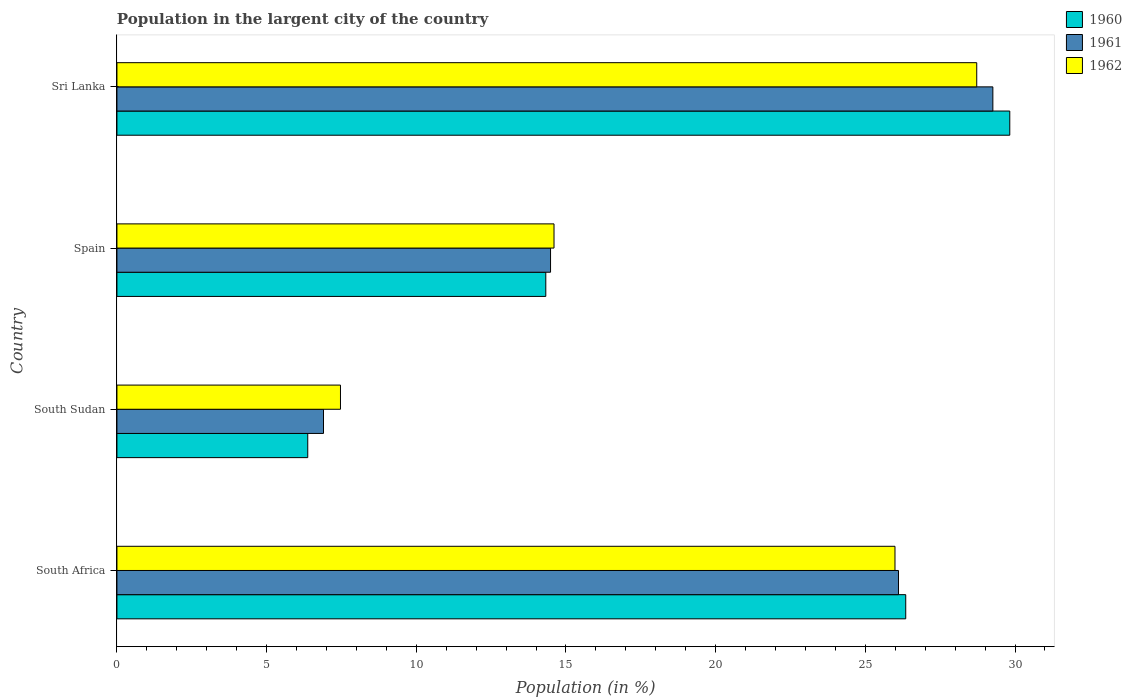How many different coloured bars are there?
Keep it short and to the point. 3. Are the number of bars on each tick of the Y-axis equal?
Offer a terse response. Yes. How many bars are there on the 2nd tick from the top?
Your answer should be very brief. 3. How many bars are there on the 2nd tick from the bottom?
Provide a short and direct response. 3. What is the label of the 1st group of bars from the top?
Provide a succinct answer. Sri Lanka. What is the percentage of population in the largent city in 1960 in Sri Lanka?
Give a very brief answer. 29.82. Across all countries, what is the maximum percentage of population in the largent city in 1960?
Provide a short and direct response. 29.82. Across all countries, what is the minimum percentage of population in the largent city in 1961?
Provide a succinct answer. 6.9. In which country was the percentage of population in the largent city in 1960 maximum?
Your answer should be very brief. Sri Lanka. In which country was the percentage of population in the largent city in 1960 minimum?
Offer a terse response. South Sudan. What is the total percentage of population in the largent city in 1961 in the graph?
Keep it short and to the point. 76.75. What is the difference between the percentage of population in the largent city in 1961 in South Sudan and that in Spain?
Provide a succinct answer. -7.58. What is the difference between the percentage of population in the largent city in 1962 in Spain and the percentage of population in the largent city in 1960 in South Sudan?
Give a very brief answer. 8.23. What is the average percentage of population in the largent city in 1962 per country?
Provide a succinct answer. 19.19. What is the difference between the percentage of population in the largent city in 1960 and percentage of population in the largent city in 1962 in Sri Lanka?
Keep it short and to the point. 1.1. What is the ratio of the percentage of population in the largent city in 1961 in South Sudan to that in Spain?
Give a very brief answer. 0.48. What is the difference between the highest and the second highest percentage of population in the largent city in 1962?
Provide a succinct answer. 2.73. What is the difference between the highest and the lowest percentage of population in the largent city in 1961?
Provide a succinct answer. 22.36. In how many countries, is the percentage of population in the largent city in 1962 greater than the average percentage of population in the largent city in 1962 taken over all countries?
Your answer should be very brief. 2. What is the difference between two consecutive major ticks on the X-axis?
Your answer should be very brief. 5. Are the values on the major ticks of X-axis written in scientific E-notation?
Keep it short and to the point. No. Does the graph contain any zero values?
Offer a very short reply. No. Does the graph contain grids?
Make the answer very short. No. How are the legend labels stacked?
Provide a short and direct response. Vertical. What is the title of the graph?
Ensure brevity in your answer.  Population in the largent city of the country. What is the label or title of the Y-axis?
Keep it short and to the point. Country. What is the Population (in %) in 1960 in South Africa?
Give a very brief answer. 26.35. What is the Population (in %) in 1961 in South Africa?
Your response must be concise. 26.11. What is the Population (in %) of 1962 in South Africa?
Your answer should be very brief. 25.99. What is the Population (in %) of 1960 in South Sudan?
Make the answer very short. 6.37. What is the Population (in %) of 1961 in South Sudan?
Your answer should be compact. 6.9. What is the Population (in %) in 1962 in South Sudan?
Ensure brevity in your answer.  7.47. What is the Population (in %) in 1960 in Spain?
Provide a succinct answer. 14.33. What is the Population (in %) of 1961 in Spain?
Provide a short and direct response. 14.48. What is the Population (in %) of 1962 in Spain?
Make the answer very short. 14.6. What is the Population (in %) in 1960 in Sri Lanka?
Provide a succinct answer. 29.82. What is the Population (in %) in 1961 in Sri Lanka?
Offer a terse response. 29.26. What is the Population (in %) in 1962 in Sri Lanka?
Give a very brief answer. 28.72. Across all countries, what is the maximum Population (in %) in 1960?
Make the answer very short. 29.82. Across all countries, what is the maximum Population (in %) of 1961?
Ensure brevity in your answer.  29.26. Across all countries, what is the maximum Population (in %) in 1962?
Ensure brevity in your answer.  28.72. Across all countries, what is the minimum Population (in %) in 1960?
Offer a terse response. 6.37. Across all countries, what is the minimum Population (in %) in 1961?
Keep it short and to the point. 6.9. Across all countries, what is the minimum Population (in %) in 1962?
Ensure brevity in your answer.  7.47. What is the total Population (in %) of 1960 in the graph?
Offer a terse response. 76.87. What is the total Population (in %) of 1961 in the graph?
Provide a short and direct response. 76.75. What is the total Population (in %) in 1962 in the graph?
Provide a short and direct response. 76.78. What is the difference between the Population (in %) of 1960 in South Africa and that in South Sudan?
Offer a terse response. 19.97. What is the difference between the Population (in %) in 1961 in South Africa and that in South Sudan?
Provide a short and direct response. 19.21. What is the difference between the Population (in %) of 1962 in South Africa and that in South Sudan?
Ensure brevity in your answer.  18.52. What is the difference between the Population (in %) in 1960 in South Africa and that in Spain?
Your answer should be very brief. 12.02. What is the difference between the Population (in %) in 1961 in South Africa and that in Spain?
Your response must be concise. 11.62. What is the difference between the Population (in %) in 1962 in South Africa and that in Spain?
Keep it short and to the point. 11.39. What is the difference between the Population (in %) in 1960 in South Africa and that in Sri Lanka?
Provide a succinct answer. -3.48. What is the difference between the Population (in %) of 1961 in South Africa and that in Sri Lanka?
Your answer should be compact. -3.15. What is the difference between the Population (in %) of 1962 in South Africa and that in Sri Lanka?
Ensure brevity in your answer.  -2.73. What is the difference between the Population (in %) of 1960 in South Sudan and that in Spain?
Provide a short and direct response. -7.95. What is the difference between the Population (in %) in 1961 in South Sudan and that in Spain?
Offer a very short reply. -7.58. What is the difference between the Population (in %) of 1962 in South Sudan and that in Spain?
Provide a succinct answer. -7.13. What is the difference between the Population (in %) in 1960 in South Sudan and that in Sri Lanka?
Provide a succinct answer. -23.45. What is the difference between the Population (in %) of 1961 in South Sudan and that in Sri Lanka?
Give a very brief answer. -22.36. What is the difference between the Population (in %) in 1962 in South Sudan and that in Sri Lanka?
Offer a very short reply. -21.25. What is the difference between the Population (in %) in 1960 in Spain and that in Sri Lanka?
Your answer should be very brief. -15.5. What is the difference between the Population (in %) in 1961 in Spain and that in Sri Lanka?
Provide a short and direct response. -14.78. What is the difference between the Population (in %) of 1962 in Spain and that in Sri Lanka?
Your answer should be very brief. -14.12. What is the difference between the Population (in %) of 1960 in South Africa and the Population (in %) of 1961 in South Sudan?
Provide a short and direct response. 19.45. What is the difference between the Population (in %) of 1960 in South Africa and the Population (in %) of 1962 in South Sudan?
Give a very brief answer. 18.88. What is the difference between the Population (in %) in 1961 in South Africa and the Population (in %) in 1962 in South Sudan?
Ensure brevity in your answer.  18.64. What is the difference between the Population (in %) of 1960 in South Africa and the Population (in %) of 1961 in Spain?
Provide a short and direct response. 11.86. What is the difference between the Population (in %) of 1960 in South Africa and the Population (in %) of 1962 in Spain?
Offer a terse response. 11.75. What is the difference between the Population (in %) in 1961 in South Africa and the Population (in %) in 1962 in Spain?
Offer a very short reply. 11.51. What is the difference between the Population (in %) of 1960 in South Africa and the Population (in %) of 1961 in Sri Lanka?
Offer a very short reply. -2.91. What is the difference between the Population (in %) in 1960 in South Africa and the Population (in %) in 1962 in Sri Lanka?
Your response must be concise. -2.37. What is the difference between the Population (in %) in 1961 in South Africa and the Population (in %) in 1962 in Sri Lanka?
Your response must be concise. -2.61. What is the difference between the Population (in %) in 1960 in South Sudan and the Population (in %) in 1961 in Spain?
Your response must be concise. -8.11. What is the difference between the Population (in %) of 1960 in South Sudan and the Population (in %) of 1962 in Spain?
Make the answer very short. -8.23. What is the difference between the Population (in %) in 1961 in South Sudan and the Population (in %) in 1962 in Spain?
Keep it short and to the point. -7.7. What is the difference between the Population (in %) in 1960 in South Sudan and the Population (in %) in 1961 in Sri Lanka?
Offer a terse response. -22.89. What is the difference between the Population (in %) of 1960 in South Sudan and the Population (in %) of 1962 in Sri Lanka?
Ensure brevity in your answer.  -22.35. What is the difference between the Population (in %) of 1961 in South Sudan and the Population (in %) of 1962 in Sri Lanka?
Offer a terse response. -21.82. What is the difference between the Population (in %) in 1960 in Spain and the Population (in %) in 1961 in Sri Lanka?
Your answer should be compact. -14.93. What is the difference between the Population (in %) in 1960 in Spain and the Population (in %) in 1962 in Sri Lanka?
Make the answer very short. -14.39. What is the difference between the Population (in %) of 1961 in Spain and the Population (in %) of 1962 in Sri Lanka?
Your answer should be compact. -14.24. What is the average Population (in %) of 1960 per country?
Keep it short and to the point. 19.22. What is the average Population (in %) of 1961 per country?
Ensure brevity in your answer.  19.19. What is the average Population (in %) in 1962 per country?
Keep it short and to the point. 19.19. What is the difference between the Population (in %) of 1960 and Population (in %) of 1961 in South Africa?
Offer a very short reply. 0.24. What is the difference between the Population (in %) in 1960 and Population (in %) in 1962 in South Africa?
Offer a very short reply. 0.36. What is the difference between the Population (in %) of 1961 and Population (in %) of 1962 in South Africa?
Keep it short and to the point. 0.12. What is the difference between the Population (in %) of 1960 and Population (in %) of 1961 in South Sudan?
Your response must be concise. -0.53. What is the difference between the Population (in %) in 1960 and Population (in %) in 1962 in South Sudan?
Keep it short and to the point. -1.09. What is the difference between the Population (in %) in 1961 and Population (in %) in 1962 in South Sudan?
Make the answer very short. -0.57. What is the difference between the Population (in %) in 1960 and Population (in %) in 1961 in Spain?
Ensure brevity in your answer.  -0.16. What is the difference between the Population (in %) in 1960 and Population (in %) in 1962 in Spain?
Provide a succinct answer. -0.27. What is the difference between the Population (in %) in 1961 and Population (in %) in 1962 in Spain?
Make the answer very short. -0.12. What is the difference between the Population (in %) of 1960 and Population (in %) of 1961 in Sri Lanka?
Your response must be concise. 0.57. What is the difference between the Population (in %) in 1960 and Population (in %) in 1962 in Sri Lanka?
Make the answer very short. 1.1. What is the difference between the Population (in %) of 1961 and Population (in %) of 1962 in Sri Lanka?
Your response must be concise. 0.54. What is the ratio of the Population (in %) in 1960 in South Africa to that in South Sudan?
Give a very brief answer. 4.13. What is the ratio of the Population (in %) in 1961 in South Africa to that in South Sudan?
Provide a short and direct response. 3.78. What is the ratio of the Population (in %) in 1962 in South Africa to that in South Sudan?
Make the answer very short. 3.48. What is the ratio of the Population (in %) in 1960 in South Africa to that in Spain?
Offer a very short reply. 1.84. What is the ratio of the Population (in %) of 1961 in South Africa to that in Spain?
Make the answer very short. 1.8. What is the ratio of the Population (in %) in 1962 in South Africa to that in Spain?
Provide a short and direct response. 1.78. What is the ratio of the Population (in %) in 1960 in South Africa to that in Sri Lanka?
Offer a terse response. 0.88. What is the ratio of the Population (in %) in 1961 in South Africa to that in Sri Lanka?
Make the answer very short. 0.89. What is the ratio of the Population (in %) in 1962 in South Africa to that in Sri Lanka?
Ensure brevity in your answer.  0.9. What is the ratio of the Population (in %) in 1960 in South Sudan to that in Spain?
Keep it short and to the point. 0.44. What is the ratio of the Population (in %) in 1961 in South Sudan to that in Spain?
Ensure brevity in your answer.  0.48. What is the ratio of the Population (in %) of 1962 in South Sudan to that in Spain?
Your answer should be compact. 0.51. What is the ratio of the Population (in %) in 1960 in South Sudan to that in Sri Lanka?
Your answer should be very brief. 0.21. What is the ratio of the Population (in %) of 1961 in South Sudan to that in Sri Lanka?
Offer a very short reply. 0.24. What is the ratio of the Population (in %) in 1962 in South Sudan to that in Sri Lanka?
Offer a terse response. 0.26. What is the ratio of the Population (in %) in 1960 in Spain to that in Sri Lanka?
Give a very brief answer. 0.48. What is the ratio of the Population (in %) in 1961 in Spain to that in Sri Lanka?
Make the answer very short. 0.49. What is the ratio of the Population (in %) in 1962 in Spain to that in Sri Lanka?
Provide a succinct answer. 0.51. What is the difference between the highest and the second highest Population (in %) in 1960?
Your answer should be very brief. 3.48. What is the difference between the highest and the second highest Population (in %) of 1961?
Offer a very short reply. 3.15. What is the difference between the highest and the second highest Population (in %) in 1962?
Keep it short and to the point. 2.73. What is the difference between the highest and the lowest Population (in %) of 1960?
Give a very brief answer. 23.45. What is the difference between the highest and the lowest Population (in %) of 1961?
Offer a very short reply. 22.36. What is the difference between the highest and the lowest Population (in %) of 1962?
Offer a terse response. 21.25. 